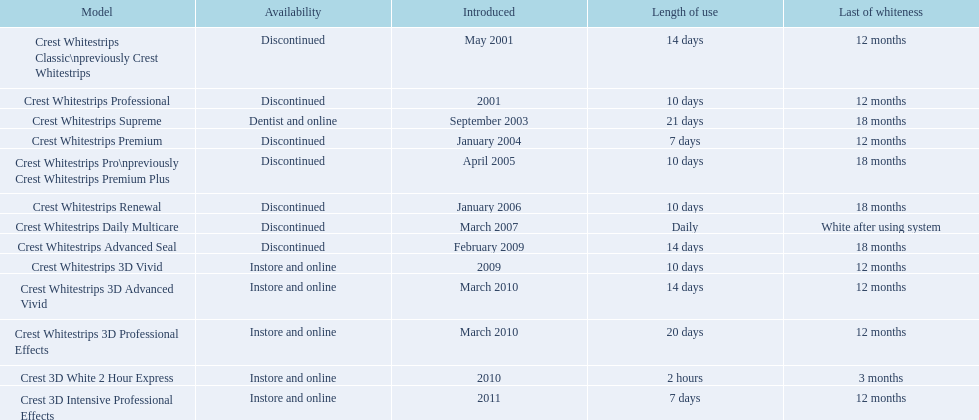What models are currently obtainable? Crest Whitestrips Supreme, Crest Whitestrips 3D Vivid, Crest Whitestrips 3D Advanced Vivid, Crest Whitestrips 3D Professional Effects, Crest 3D White 2 Hour Express, Crest 3D Intensive Professional Effects. Of these, which ones made their debut before 2011? Crest Whitestrips Supreme, Crest Whitestrips 3D Vivid, Crest Whitestrips 3D Advanced Vivid, Crest Whitestrips 3D Professional Effects, Crest 3D White 2 Hour Express. Taking into account those models, which ones demanded a 14-day minimum usage? Crest Whitestrips Supreme, Crest Whitestrips 3D Advanced Vivid, Crest Whitestrips 3D Professional Effects. Among these, which ones persisted for longer than a year? Crest Whitestrips Supreme. 